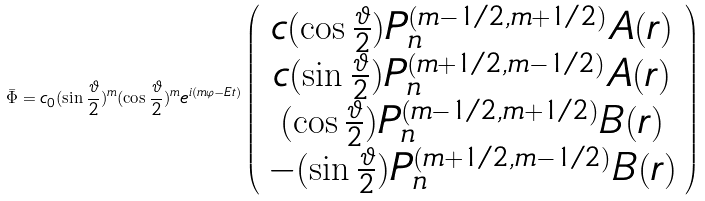<formula> <loc_0><loc_0><loc_500><loc_500>\bar { \Phi } = c _ { 0 } ( \sin \frac { \vartheta } { 2 } ) ^ { m } ( \cos \frac { \vartheta } { 2 } ) ^ { m } e ^ { i ( m \varphi - E t ) } \left ( \begin{array} { c } { { c ( \cos \frac { \vartheta } { 2 } ) P _ { n } ^ { ( m - 1 / 2 , m + 1 / 2 ) } A ( r ) } } \\ { { c ( \sin \frac { \vartheta } { 2 } ) P _ { n } ^ { ( m + 1 / 2 , m - 1 / 2 ) } A ( r ) } } \\ { { ( \cos \frac { \vartheta } { 2 } ) P _ { n } ^ { ( m - 1 / 2 , m + 1 / 2 ) } B ( r ) } } \\ { { - ( \sin \frac { \vartheta } { 2 } ) P _ { n } ^ { ( m + 1 / 2 , m - 1 / 2 ) } B ( r ) } } \end{array} \right )</formula> 